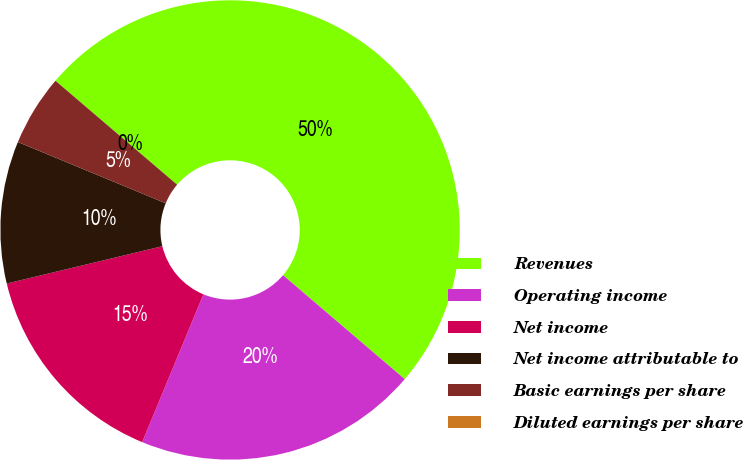Convert chart. <chart><loc_0><loc_0><loc_500><loc_500><pie_chart><fcel>Revenues<fcel>Operating income<fcel>Net income<fcel>Net income attributable to<fcel>Basic earnings per share<fcel>Diluted earnings per share<nl><fcel>50.0%<fcel>20.0%<fcel>15.0%<fcel>10.0%<fcel>5.0%<fcel>0.0%<nl></chart> 